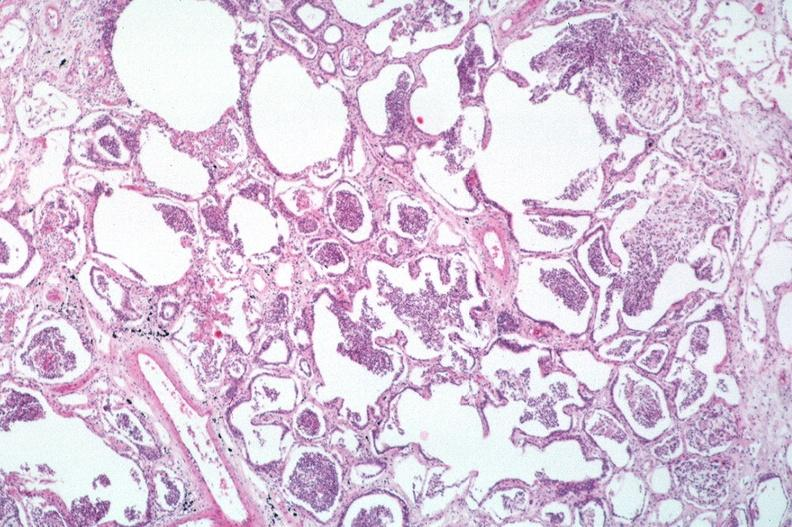where is this?
Answer the question using a single word or phrase. Lung 